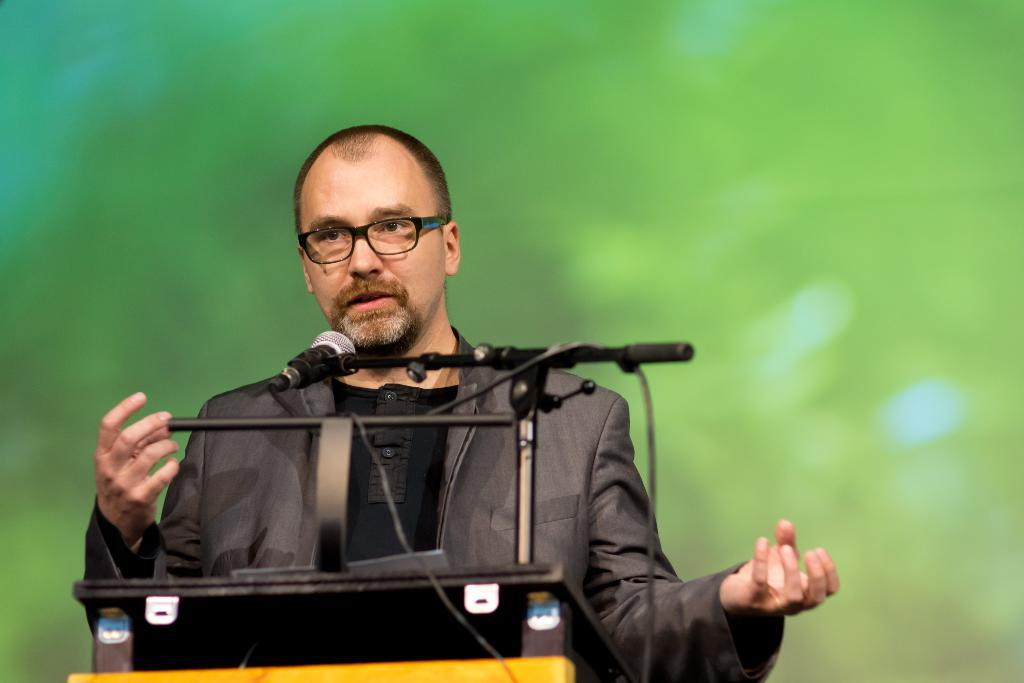What is the main subject of the image? There is a person in the center of the image. Can you describe the person's appearance? The person is wearing glasses and a coat. What object is present on the podium? There is a mic on a stand on the podium. What can be said about the background of the image? The background is not clear. What type of error can be seen on the roof in the image? There is no roof present in the image, and therefore no errors can be observed. 